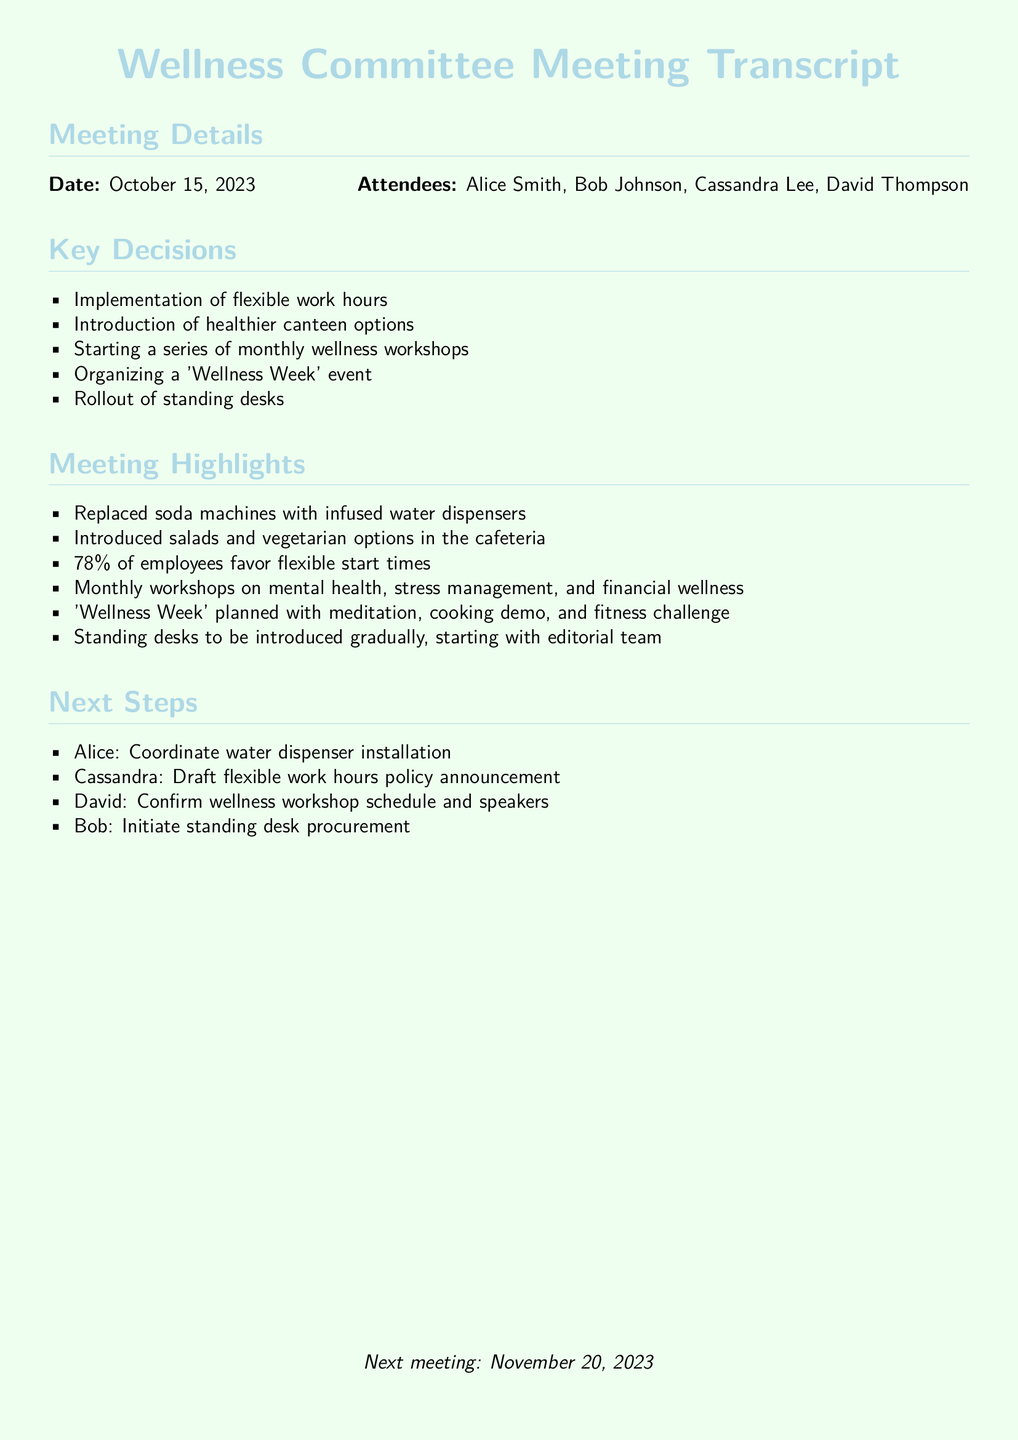What date was the meeting held? The meeting date is explicitly mentioned in the document details.
Answer: October 15, 2023 Who attended the meeting? The names of attendees are listed in the meeting details.
Answer: Alice Smith, Bob Johnson, Cassandra Lee, David Thompson What percentage of employees favor flexible start times? This percentage is provided in the meeting highlights.
Answer: 78% What is one type of event planned for 'Wellness Week'? The planned activities for 'Wellness Week' are summarised in the meeting highlights.
Answer: Meditation Who is responsible for coordinating the water dispenser installation? The next steps section outlines responsibilities assigned to each member.
Answer: Alice What new item will gradually be introduced starting with the editorial team? This item is mentioned in the key decisions and highlights sections of the document.
Answer: Standing desks What healthier options will be introduced in the canteen? The healthier options are stated in the meeting highlights.
Answer: Salads and vegetarian options What is the next meeting date? The date for the next meeting is mentioned at the end of the transcript.
Answer: November 20, 2023 What type of workshops will be held monthly? The types of workshops are specified in the meeting highlights.
Answer: Mental health, stress management, and financial wellness 